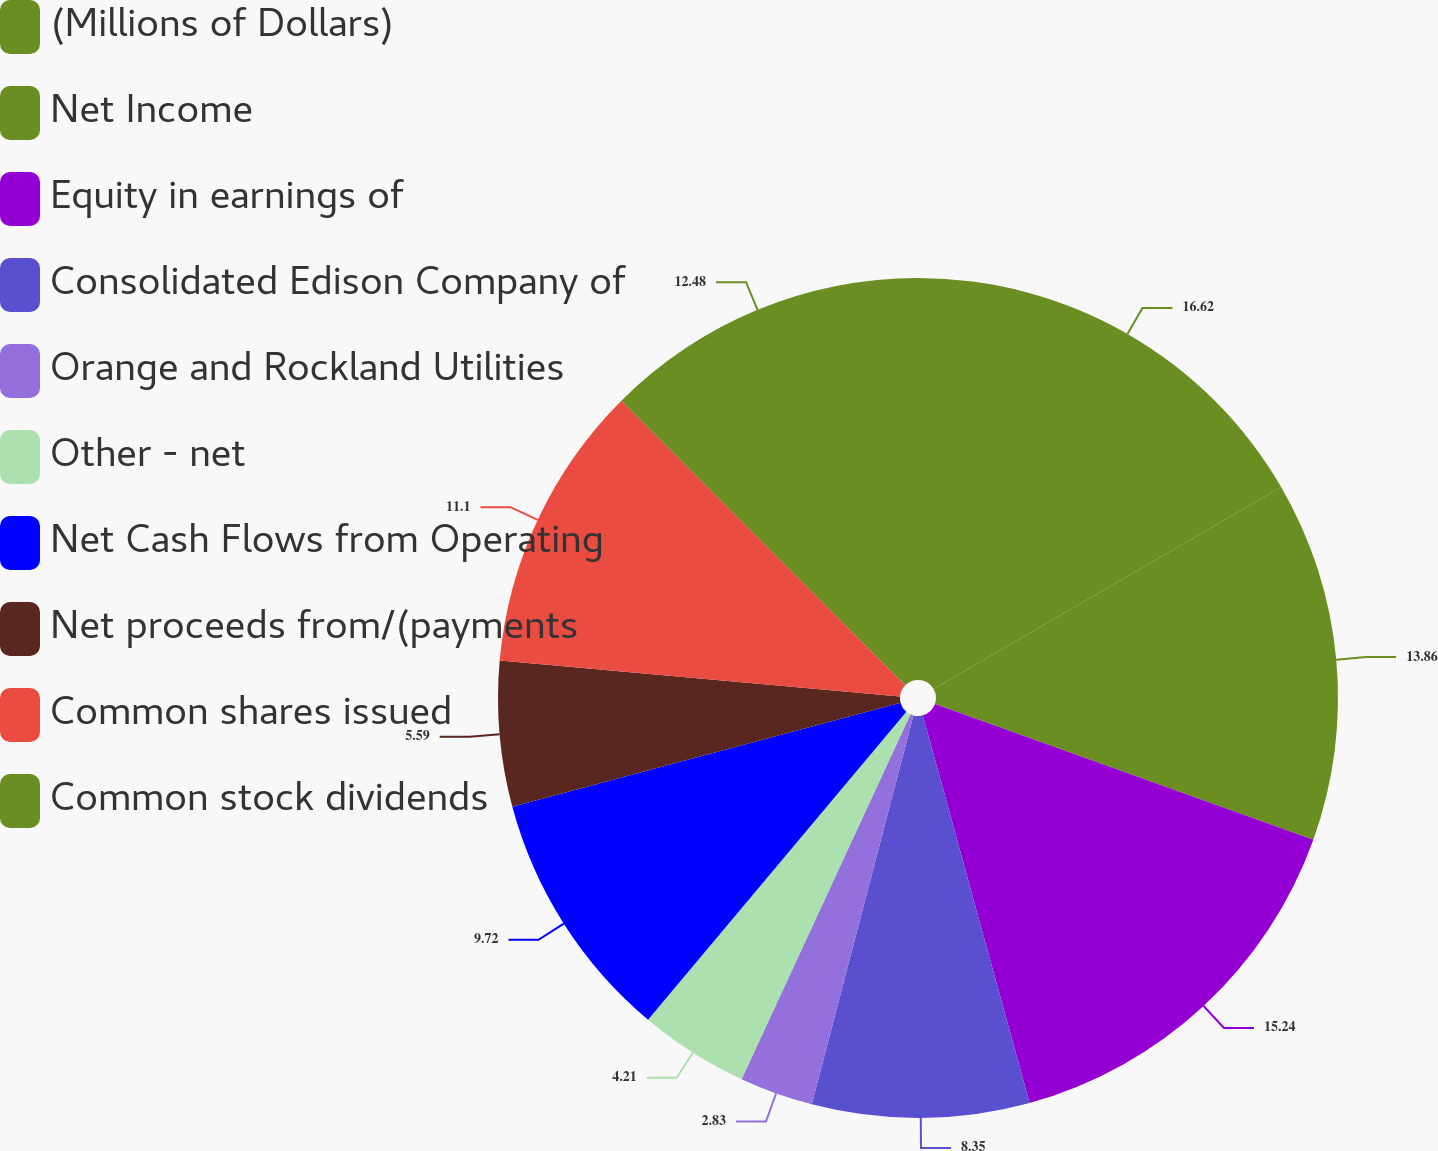Convert chart to OTSL. <chart><loc_0><loc_0><loc_500><loc_500><pie_chart><fcel>(Millions of Dollars)<fcel>Net Income<fcel>Equity in earnings of<fcel>Consolidated Edison Company of<fcel>Orange and Rockland Utilities<fcel>Other - net<fcel>Net Cash Flows from Operating<fcel>Net proceeds from/(payments<fcel>Common shares issued<fcel>Common stock dividends<nl><fcel>16.62%<fcel>13.86%<fcel>15.24%<fcel>8.35%<fcel>2.83%<fcel>4.21%<fcel>9.72%<fcel>5.59%<fcel>11.1%<fcel>12.48%<nl></chart> 